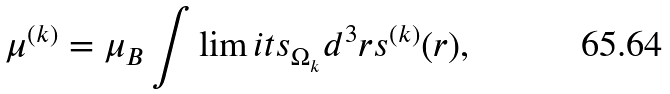<formula> <loc_0><loc_0><loc_500><loc_500>\mu ^ { ( k ) } = \mu _ { B } \int \lim i t s _ { \Omega _ { k } } d ^ { 3 } r s ^ { ( k ) } ( { r } ) ,</formula> 